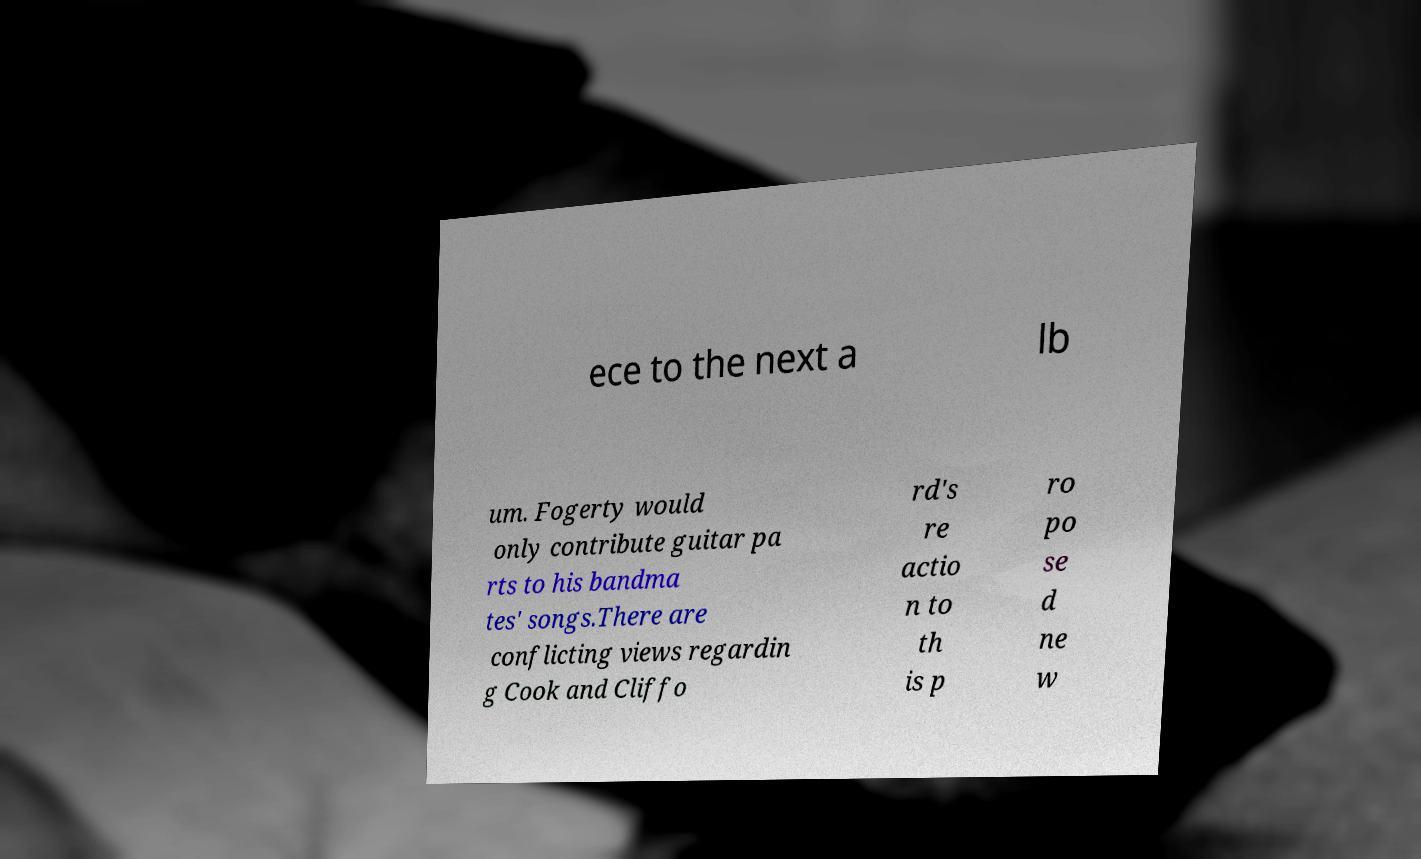Please identify and transcribe the text found in this image. ece to the next a lb um. Fogerty would only contribute guitar pa rts to his bandma tes' songs.There are conflicting views regardin g Cook and Cliffo rd's re actio n to th is p ro po se d ne w 